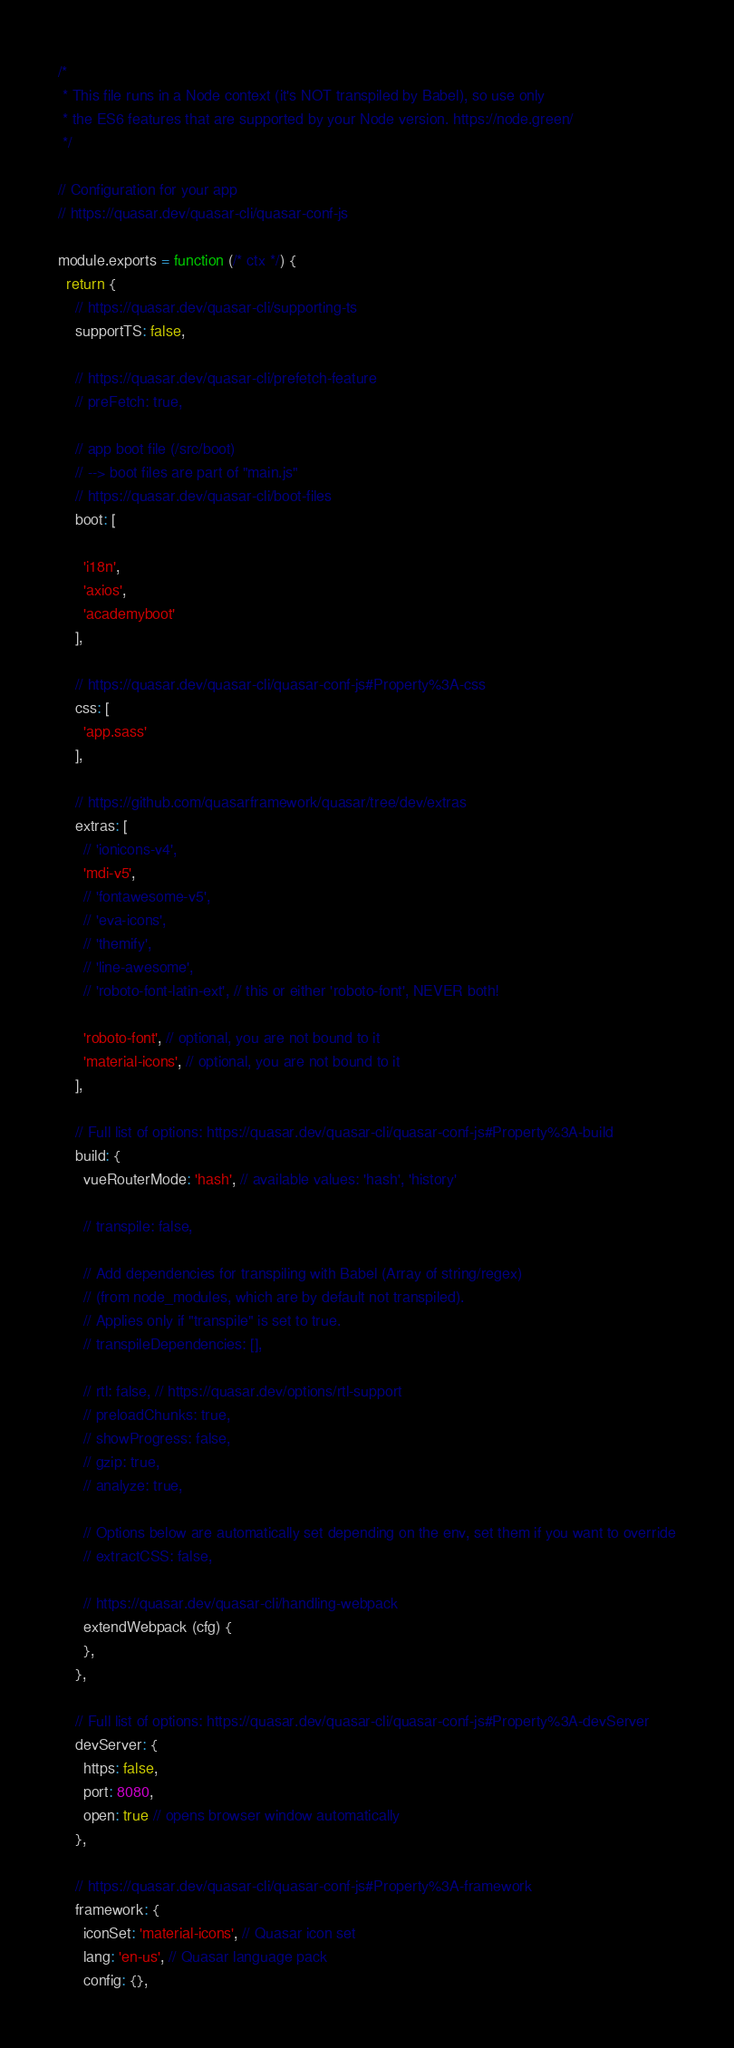Convert code to text. <code><loc_0><loc_0><loc_500><loc_500><_JavaScript_>/*
 * This file runs in a Node context (it's NOT transpiled by Babel), so use only
 * the ES6 features that are supported by your Node version. https://node.green/
 */

// Configuration for your app
// https://quasar.dev/quasar-cli/quasar-conf-js

module.exports = function (/* ctx */) {
  return {
    // https://quasar.dev/quasar-cli/supporting-ts
    supportTS: false,

    // https://quasar.dev/quasar-cli/prefetch-feature
    // preFetch: true,

    // app boot file (/src/boot)
    // --> boot files are part of "main.js"
    // https://quasar.dev/quasar-cli/boot-files
    boot: [
      
      'i18n',
      'axios',
      'academyboot'
    ],

    // https://quasar.dev/quasar-cli/quasar-conf-js#Property%3A-css
    css: [
      'app.sass'
    ],

    // https://github.com/quasarframework/quasar/tree/dev/extras
    extras: [
      // 'ionicons-v4',
      'mdi-v5',
      // 'fontawesome-v5',
      // 'eva-icons',
      // 'themify',
      // 'line-awesome',
      // 'roboto-font-latin-ext', // this or either 'roboto-font', NEVER both!

      'roboto-font', // optional, you are not bound to it
      'material-icons', // optional, you are not bound to it
    ],

    // Full list of options: https://quasar.dev/quasar-cli/quasar-conf-js#Property%3A-build
    build: {
      vueRouterMode: 'hash', // available values: 'hash', 'history'

      // transpile: false,

      // Add dependencies for transpiling with Babel (Array of string/regex)
      // (from node_modules, which are by default not transpiled).
      // Applies only if "transpile" is set to true.
      // transpileDependencies: [],

      // rtl: false, // https://quasar.dev/options/rtl-support
      // preloadChunks: true,
      // showProgress: false,
      // gzip: true,
      // analyze: true,

      // Options below are automatically set depending on the env, set them if you want to override
      // extractCSS: false,

      // https://quasar.dev/quasar-cli/handling-webpack
      extendWebpack (cfg) {
      },
    },

    // Full list of options: https://quasar.dev/quasar-cli/quasar-conf-js#Property%3A-devServer
    devServer: {
      https: false,
      port: 8080,
      open: true // opens browser window automatically
    },

    // https://quasar.dev/quasar-cli/quasar-conf-js#Property%3A-framework
    framework: {
      iconSet: 'material-icons', // Quasar icon set
      lang: 'en-us', // Quasar language pack
      config: {},
</code> 